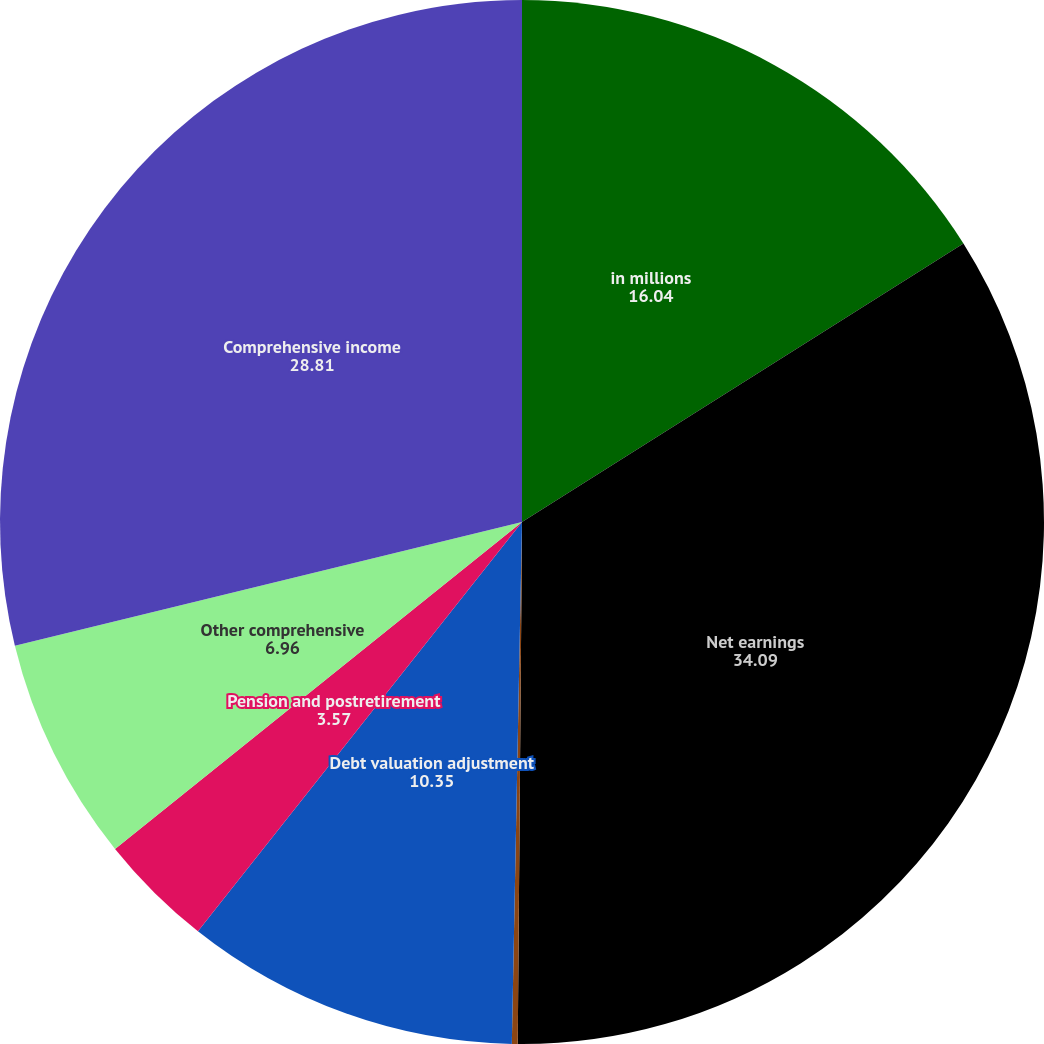<chart> <loc_0><loc_0><loc_500><loc_500><pie_chart><fcel>in millions<fcel>Net earnings<fcel>Currency translation<fcel>Debt valuation adjustment<fcel>Pension and postretirement<fcel>Other comprehensive<fcel>Comprehensive income<nl><fcel>16.04%<fcel>34.09%<fcel>0.18%<fcel>10.35%<fcel>3.57%<fcel>6.96%<fcel>28.81%<nl></chart> 